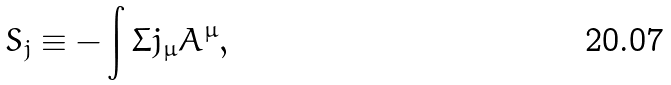Convert formula to latex. <formula><loc_0><loc_0><loc_500><loc_500>S _ { j } \equiv - \int \Sigma j _ { \mu } A ^ { \mu } ,</formula> 